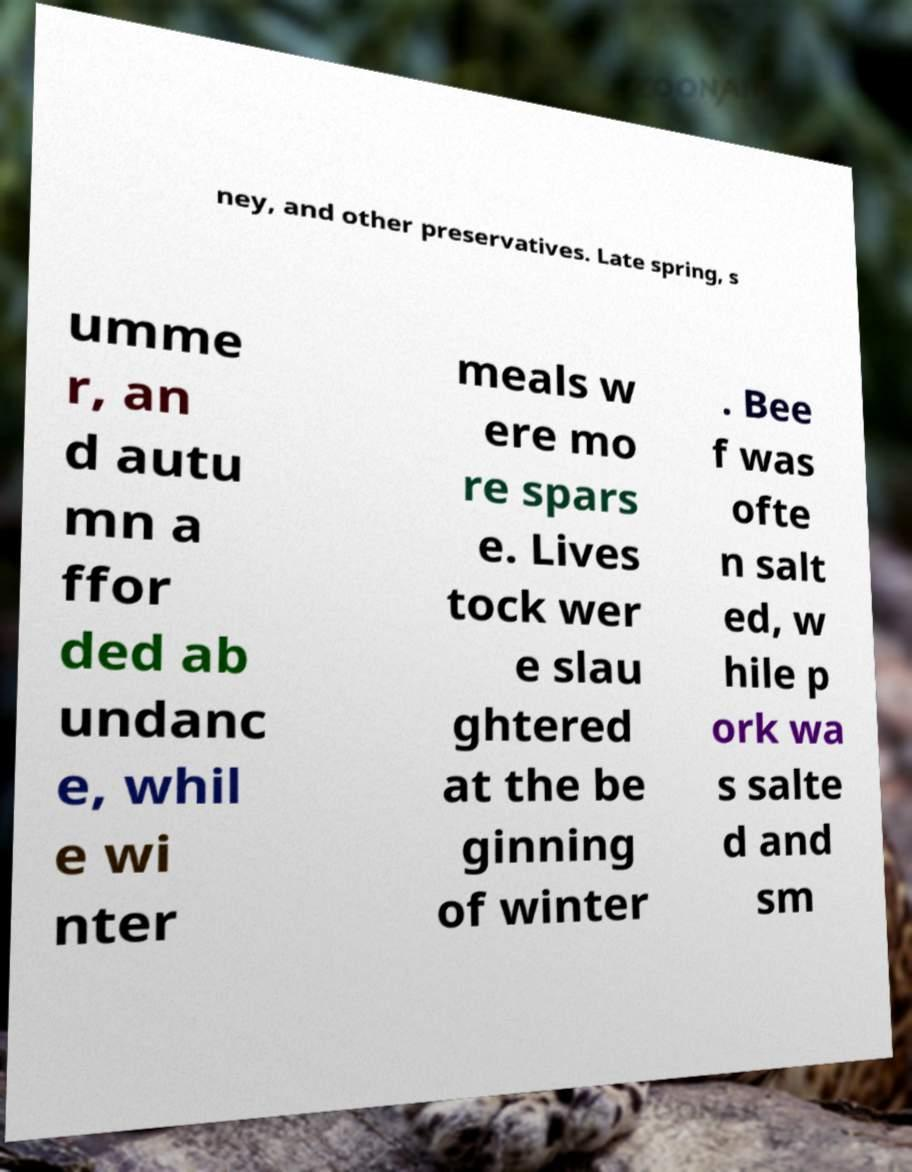I need the written content from this picture converted into text. Can you do that? ney, and other preservatives. Late spring, s umme r, an d autu mn a ffor ded ab undanc e, whil e wi nter meals w ere mo re spars e. Lives tock wer e slau ghtered at the be ginning of winter . Bee f was ofte n salt ed, w hile p ork wa s salte d and sm 